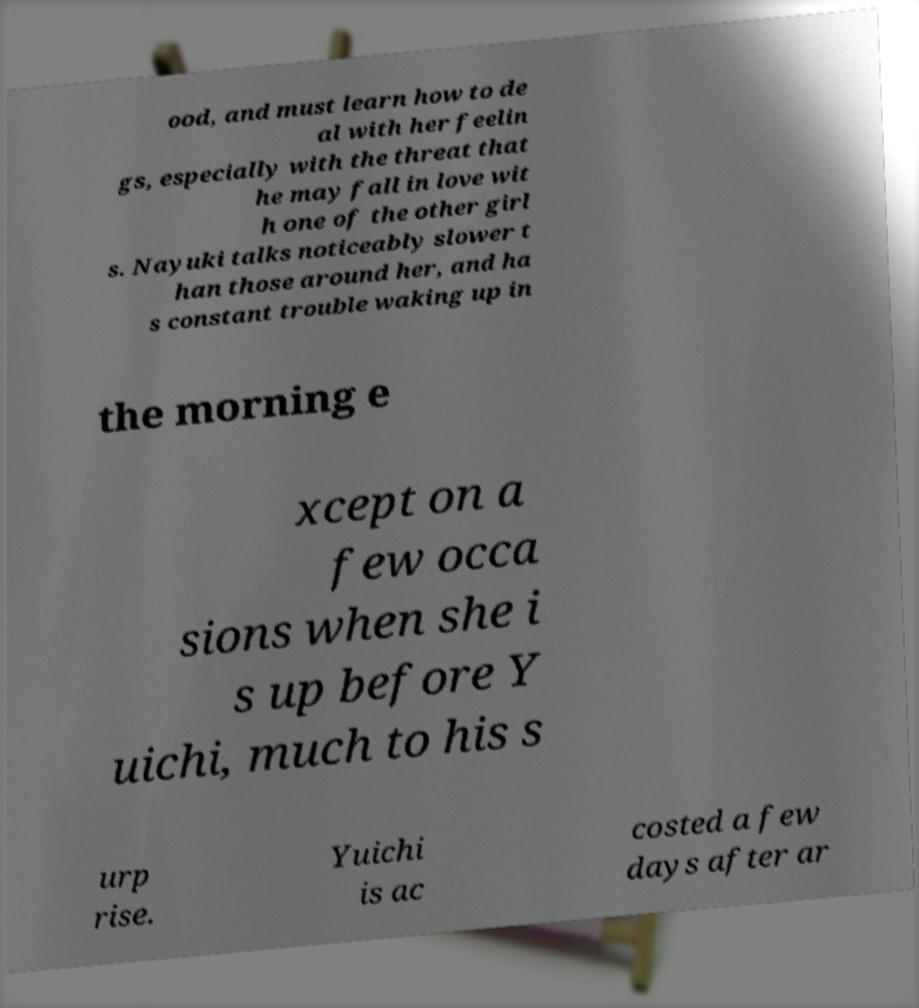There's text embedded in this image that I need extracted. Can you transcribe it verbatim? ood, and must learn how to de al with her feelin gs, especially with the threat that he may fall in love wit h one of the other girl s. Nayuki talks noticeably slower t han those around her, and ha s constant trouble waking up in the morning e xcept on a few occa sions when she i s up before Y uichi, much to his s urp rise. Yuichi is ac costed a few days after ar 